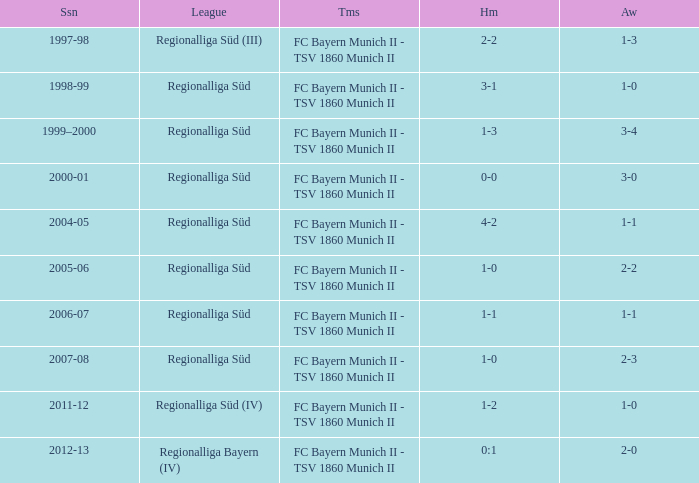What is the league with a 0:1 home? Regionalliga Bayern (IV). 